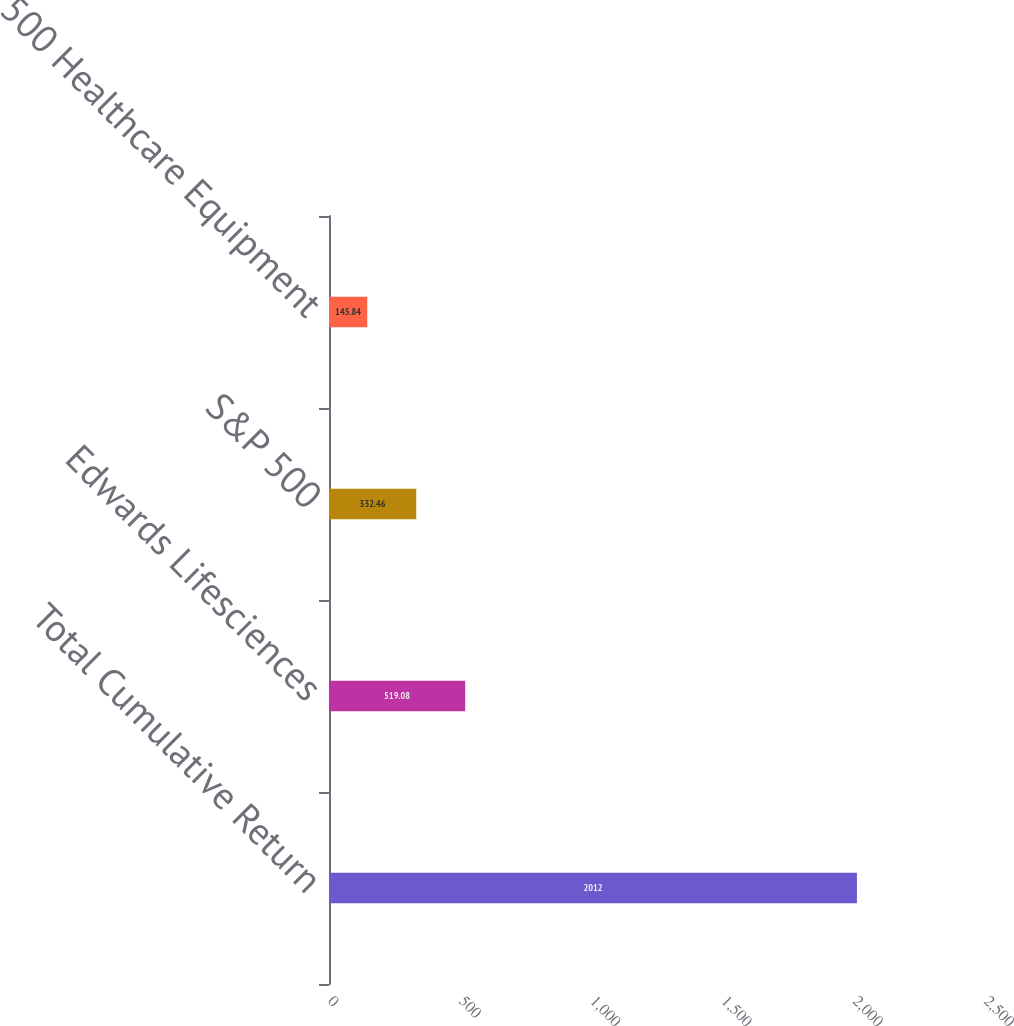Convert chart. <chart><loc_0><loc_0><loc_500><loc_500><bar_chart><fcel>Total Cumulative Return<fcel>Edwards Lifesciences<fcel>S&P 500<fcel>S&P 500 Healthcare Equipment<nl><fcel>2012<fcel>519.08<fcel>332.46<fcel>145.84<nl></chart> 